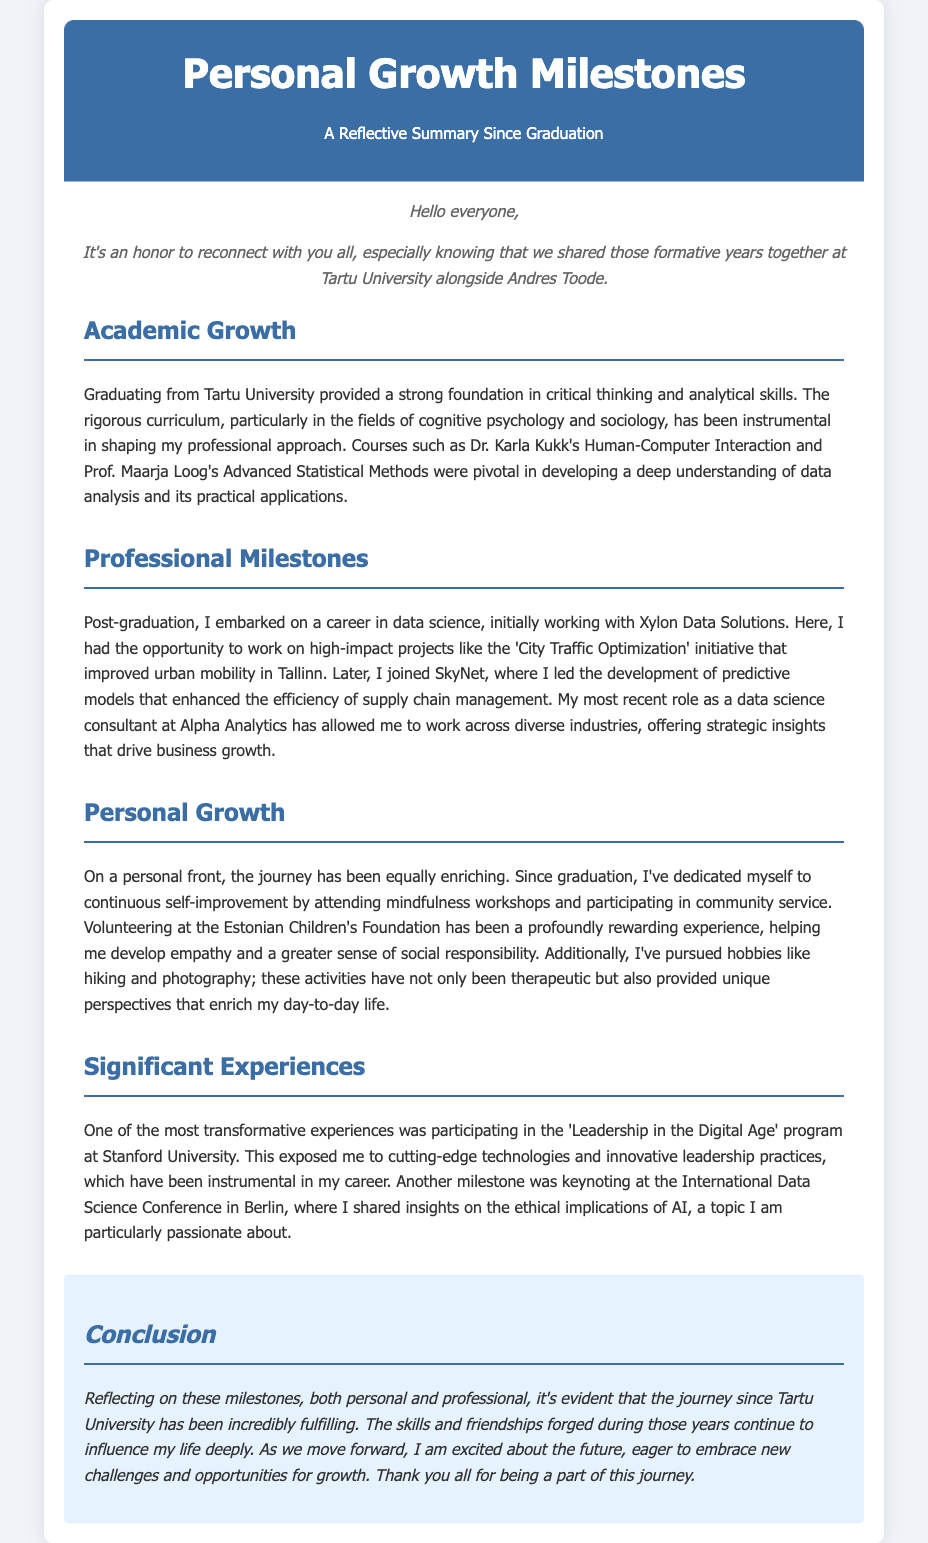what is the title of the document? The title is prominently displayed in the header of the document, which is "Personal Growth Milestones: A Reflective Summary".
Answer: Personal Growth Milestones: A Reflective Summary who were two professors mentioned in the academic section? The document lists Dr. Karla Kukk and Prof. Maarja Loog as professors who had a significant impact on the academic growth.
Answer: Dr. Karla Kukk, Prof. Maarja Loog what was the first job mentioned after graduation? The first job the author mentions post-graduation is at "Xylon Data Solutions".
Answer: Xylon Data Solutions which program did the author attend at Stanford University? The author participated in the 'Leadership in the Digital Age' program at Stanford University.
Answer: Leadership in the Digital Age what volunteer activity is highlighted in the personal growth section? The document highlights volunteering at the Estonian Children's Foundation as a significant personal growth activity.
Answer: Estonian Children's Foundation how did the author describe the journey since graduation? The author states that the journey since graduation has been "incredibly fulfilling".
Answer: incredibly fulfilling what is the main focus of the author's most recent role? The main focus of the author's most recent role is providing "strategic insights that drive business growth".
Answer: strategic insights that drive business growth which city was impacted by the 'City Traffic Optimization' initiative? The 'City Traffic Optimization' initiative aimed to improve urban mobility in "Tallinn".
Answer: Tallinn what topic did the author share insights on at the International Data Science Conference? The author discussed "the ethical implications of AI" at the conference.
Answer: the ethical implications of AI 